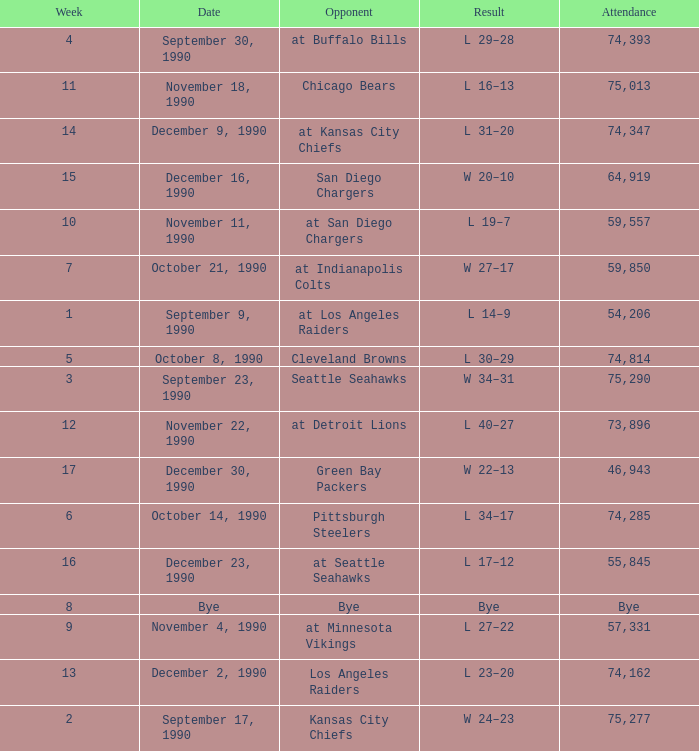What was the result for week 16? L 17–12. 